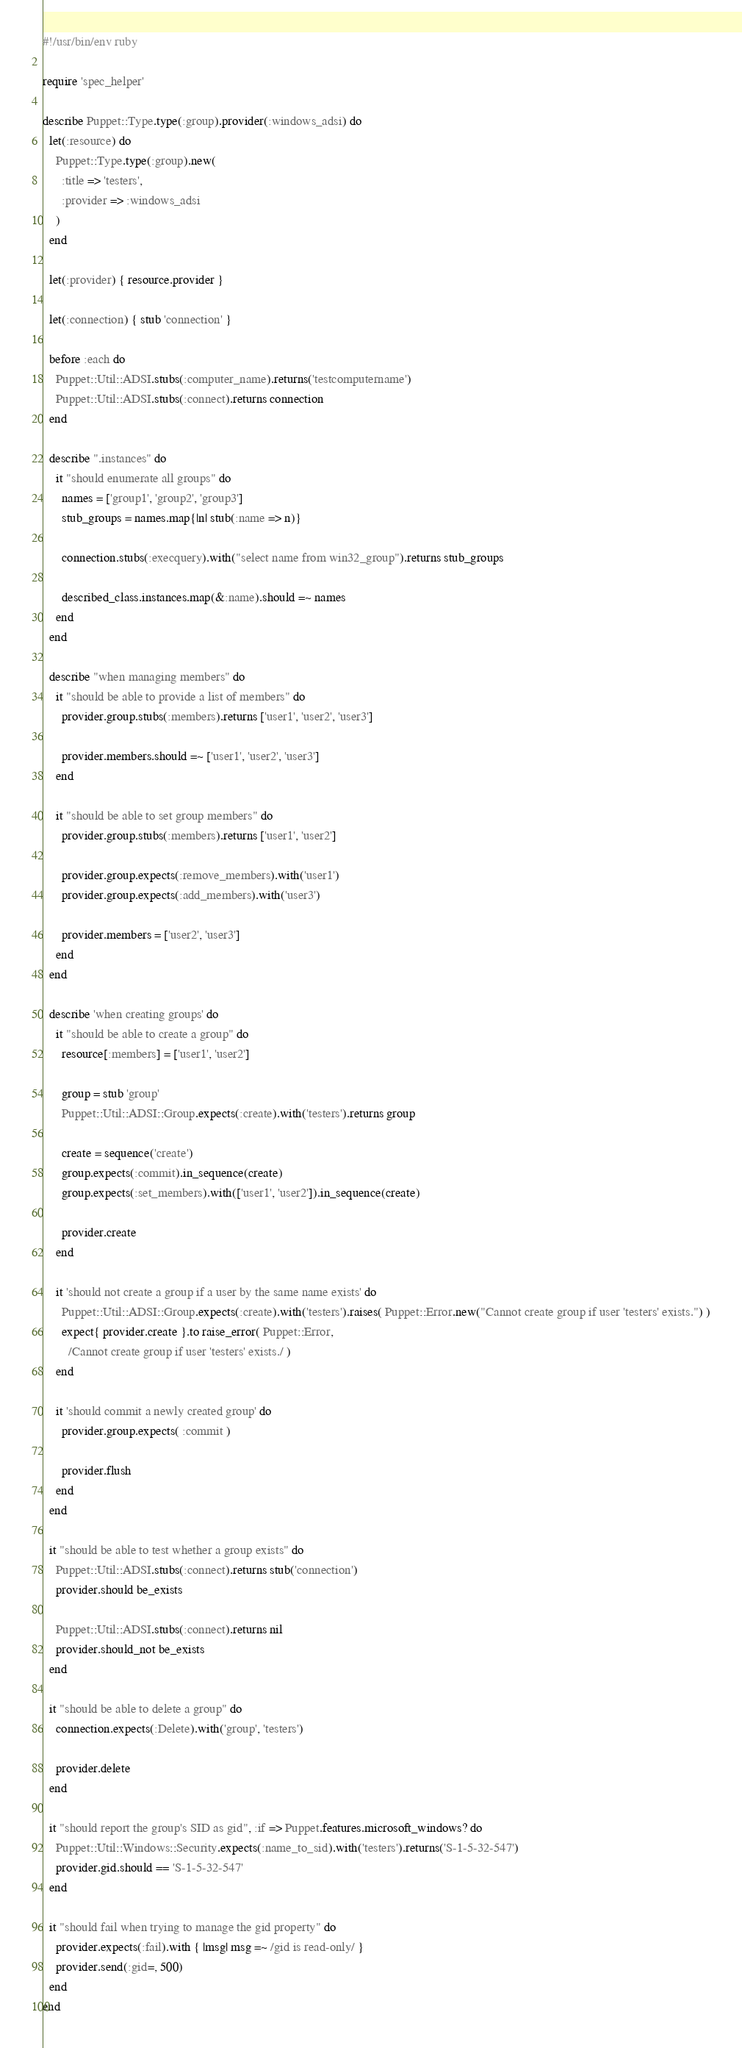<code> <loc_0><loc_0><loc_500><loc_500><_Ruby_>#!/usr/bin/env ruby

require 'spec_helper'

describe Puppet::Type.type(:group).provider(:windows_adsi) do
  let(:resource) do
    Puppet::Type.type(:group).new(
      :title => 'testers',
      :provider => :windows_adsi
    )
  end

  let(:provider) { resource.provider }

  let(:connection) { stub 'connection' }

  before :each do
    Puppet::Util::ADSI.stubs(:computer_name).returns('testcomputername')
    Puppet::Util::ADSI.stubs(:connect).returns connection
  end

  describe ".instances" do
    it "should enumerate all groups" do
      names = ['group1', 'group2', 'group3']
      stub_groups = names.map{|n| stub(:name => n)}

      connection.stubs(:execquery).with("select name from win32_group").returns stub_groups

      described_class.instances.map(&:name).should =~ names
    end
  end

  describe "when managing members" do
    it "should be able to provide a list of members" do
      provider.group.stubs(:members).returns ['user1', 'user2', 'user3']

      provider.members.should =~ ['user1', 'user2', 'user3']
    end

    it "should be able to set group members" do
      provider.group.stubs(:members).returns ['user1', 'user2']

      provider.group.expects(:remove_members).with('user1')
      provider.group.expects(:add_members).with('user3')

      provider.members = ['user2', 'user3']
    end
  end

  describe 'when creating groups' do
    it "should be able to create a group" do
      resource[:members] = ['user1', 'user2']

      group = stub 'group'
      Puppet::Util::ADSI::Group.expects(:create).with('testers').returns group

      create = sequence('create')
      group.expects(:commit).in_sequence(create)
      group.expects(:set_members).with(['user1', 'user2']).in_sequence(create)

      provider.create
    end

    it 'should not create a group if a user by the same name exists' do
      Puppet::Util::ADSI::Group.expects(:create).with('testers').raises( Puppet::Error.new("Cannot create group if user 'testers' exists.") )
      expect{ provider.create }.to raise_error( Puppet::Error,
        /Cannot create group if user 'testers' exists./ )
    end

    it 'should commit a newly created group' do
      provider.group.expects( :commit )

      provider.flush
    end
  end

  it "should be able to test whether a group exists" do
    Puppet::Util::ADSI.stubs(:connect).returns stub('connection')
    provider.should be_exists

    Puppet::Util::ADSI.stubs(:connect).returns nil
    provider.should_not be_exists
  end

  it "should be able to delete a group" do
    connection.expects(:Delete).with('group', 'testers')

    provider.delete
  end

  it "should report the group's SID as gid", :if => Puppet.features.microsoft_windows? do
    Puppet::Util::Windows::Security.expects(:name_to_sid).with('testers').returns('S-1-5-32-547')
    provider.gid.should == 'S-1-5-32-547'
  end

  it "should fail when trying to manage the gid property" do
    provider.expects(:fail).with { |msg| msg =~ /gid is read-only/ }
    provider.send(:gid=, 500)
  end
end
</code> 